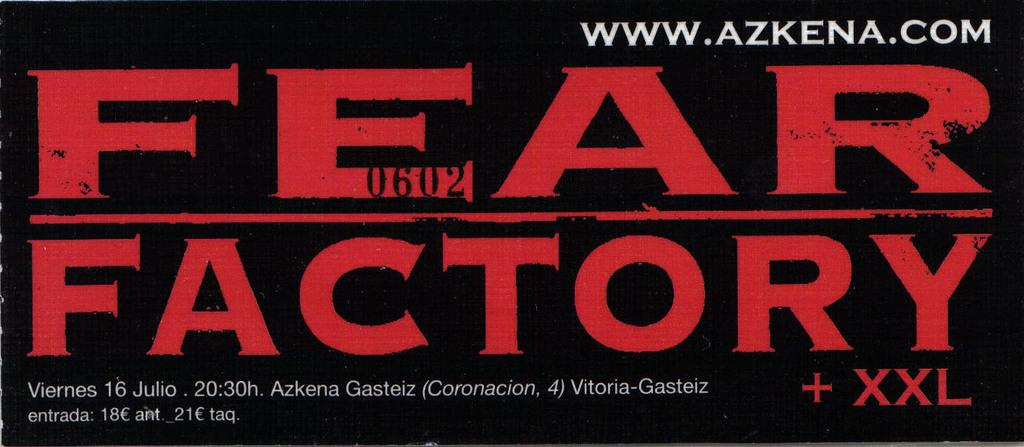<image>
Share a concise interpretation of the image provided. A image of a poster for Fear Factory + XXL with the website www.azkena.com on it is shown. 